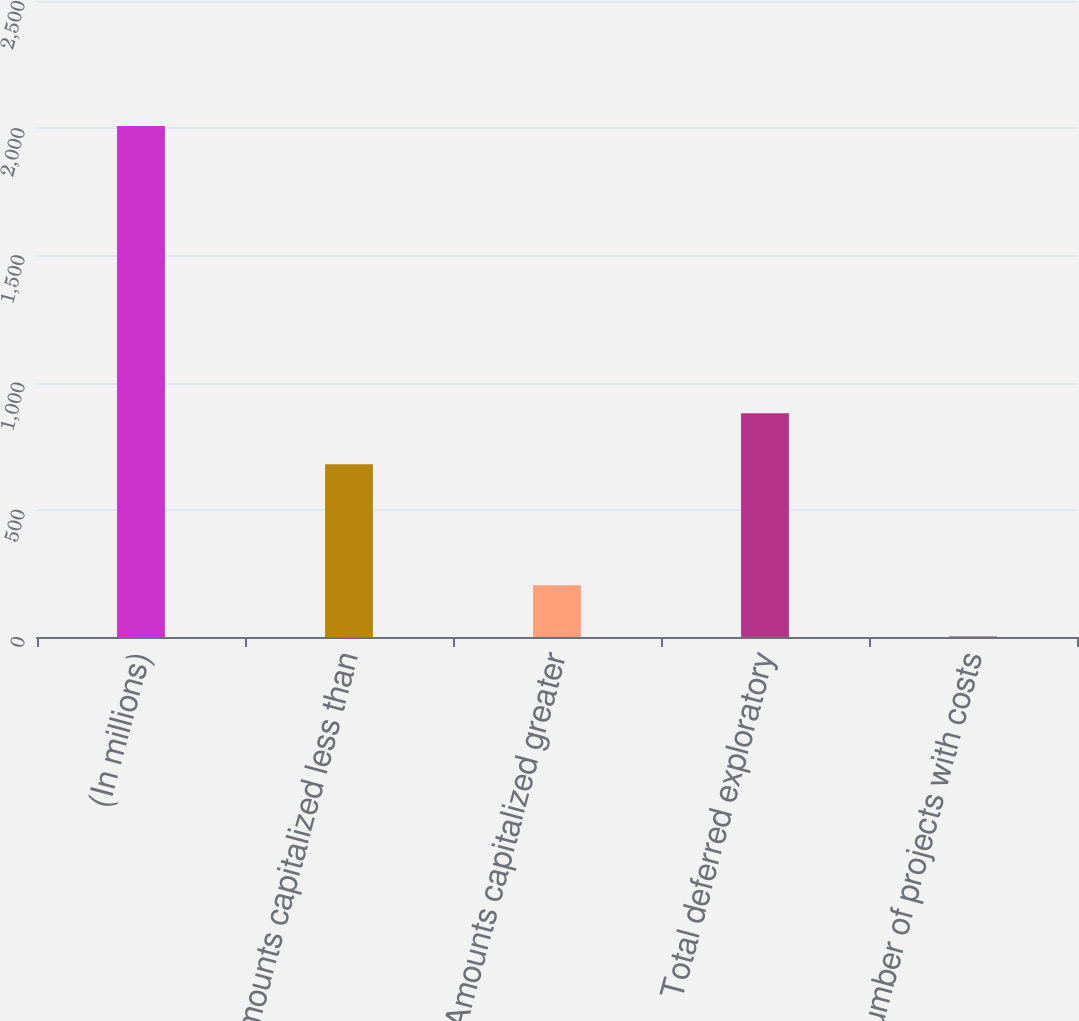Convert chart to OTSL. <chart><loc_0><loc_0><loc_500><loc_500><bar_chart><fcel>(In millions)<fcel>Amounts capitalized less than<fcel>Amounts capitalized greater<fcel>Total deferred exploratory<fcel>Number of projects with costs<nl><fcel>2009<fcel>679<fcel>203.6<fcel>879.6<fcel>3<nl></chart> 